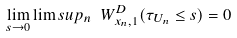<formula> <loc_0><loc_0><loc_500><loc_500>\lim _ { s \to 0 } \lim s u p _ { n } \ W ^ { D } _ { x _ { n } , 1 } ( \tau _ { U _ { n } } \leq s ) = 0</formula> 